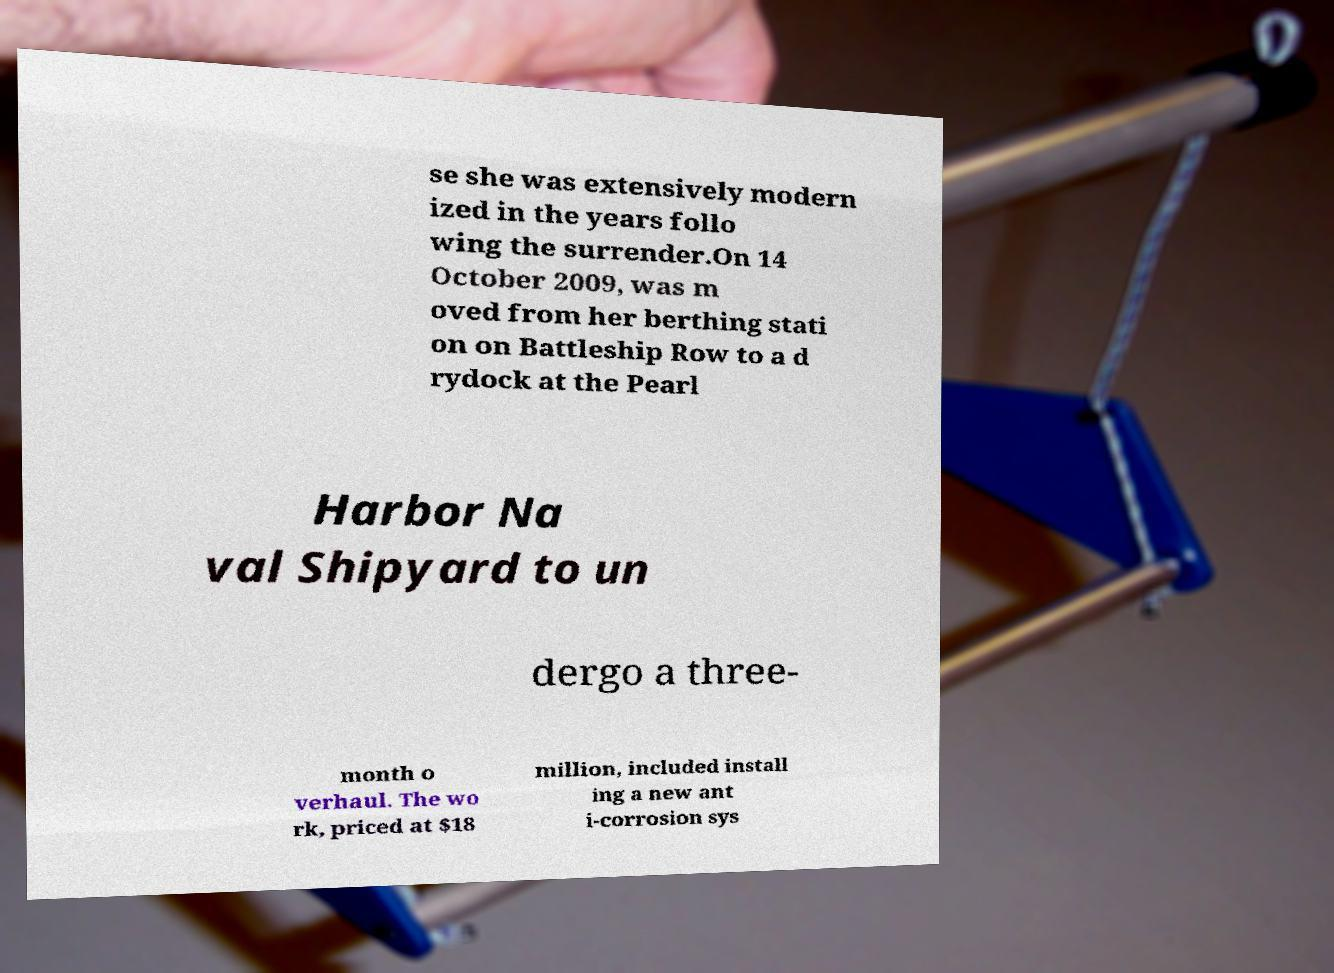Can you read and provide the text displayed in the image?This photo seems to have some interesting text. Can you extract and type it out for me? se she was extensively modern ized in the years follo wing the surrender.On 14 October 2009, was m oved from her berthing stati on on Battleship Row to a d rydock at the Pearl Harbor Na val Shipyard to un dergo a three- month o verhaul. The wo rk, priced at $18 million, included install ing a new ant i-corrosion sys 